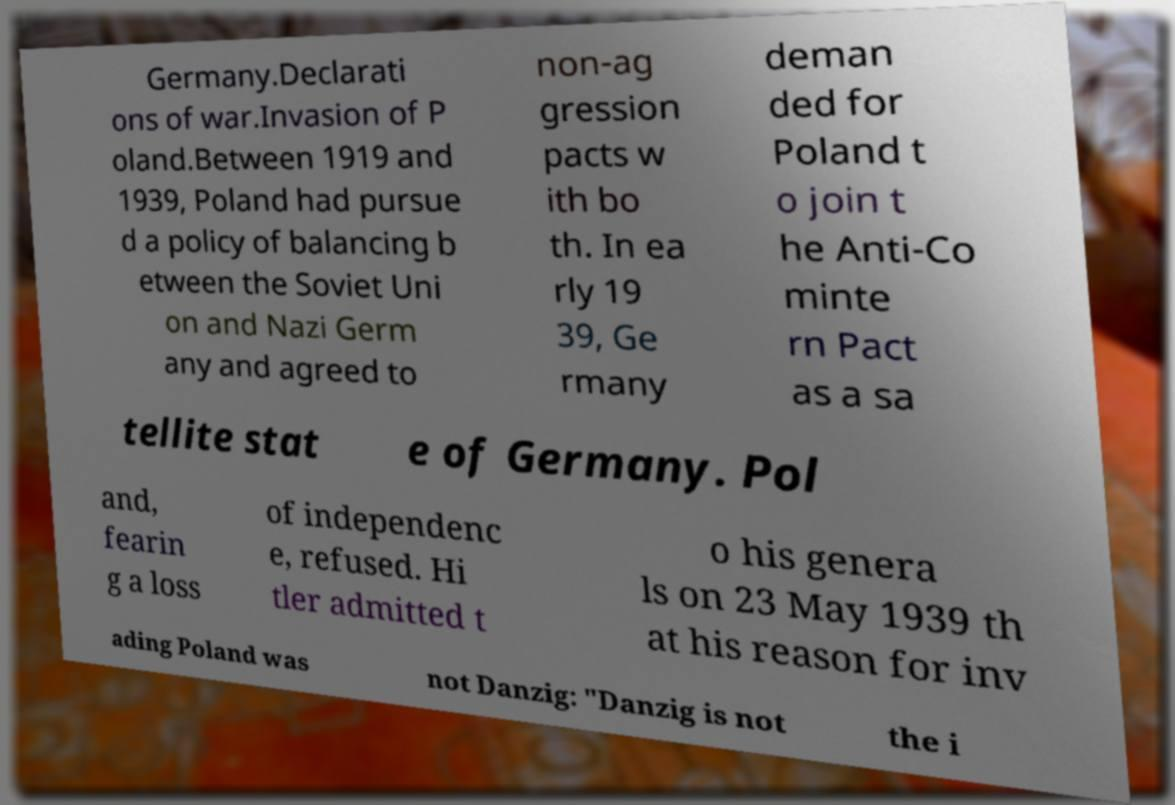For documentation purposes, I need the text within this image transcribed. Could you provide that? Germany.Declarati ons of war.Invasion of P oland.Between 1919 and 1939, Poland had pursue d a policy of balancing b etween the Soviet Uni on and Nazi Germ any and agreed to non-ag gression pacts w ith bo th. In ea rly 19 39, Ge rmany deman ded for Poland t o join t he Anti-Co minte rn Pact as a sa tellite stat e of Germany. Pol and, fearin g a loss of independenc e, refused. Hi tler admitted t o his genera ls on 23 May 1939 th at his reason for inv ading Poland was not Danzig: "Danzig is not the i 